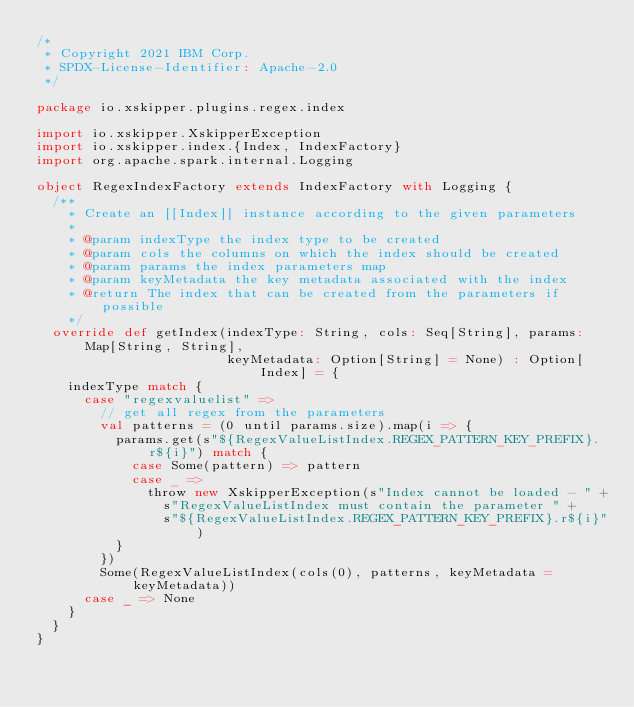<code> <loc_0><loc_0><loc_500><loc_500><_Scala_>/*
 * Copyright 2021 IBM Corp.
 * SPDX-License-Identifier: Apache-2.0
 */

package io.xskipper.plugins.regex.index

import io.xskipper.XskipperException
import io.xskipper.index.{Index, IndexFactory}
import org.apache.spark.internal.Logging

object RegexIndexFactory extends IndexFactory with Logging {
  /**
    * Create an [[Index]] instance according to the given parameters
    *
    * @param indexType the index type to be created
    * @param cols the columns on which the index should be created
    * @param params the index parameters map
    * @param keyMetadata the key metadata associated with the index
    * @return The index that can be created from the parameters if possible
    */
  override def getIndex(indexType: String, cols: Seq[String], params: Map[String, String],
                        keyMetadata: Option[String] = None) : Option[Index] = {
    indexType match {
      case "regexvaluelist" =>
        // get all regex from the parameters
        val patterns = (0 until params.size).map(i => {
          params.get(s"${RegexValueListIndex.REGEX_PATTERN_KEY_PREFIX}.r${i}") match {
            case Some(pattern) => pattern
            case _ =>
              throw new XskipperException(s"Index cannot be loaded - " +
                s"RegexValueListIndex must contain the parameter " +
                s"${RegexValueListIndex.REGEX_PATTERN_KEY_PREFIX}.r${i}")
          }
        })
        Some(RegexValueListIndex(cols(0), patterns, keyMetadata = keyMetadata))
      case _ => None
    }
  }
}
</code> 